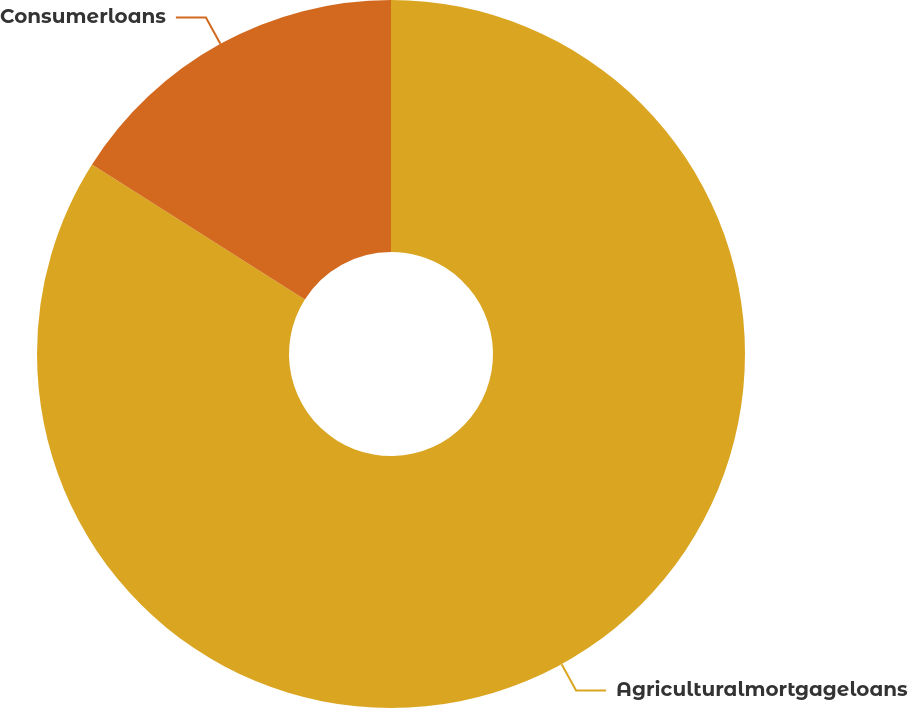Convert chart. <chart><loc_0><loc_0><loc_500><loc_500><pie_chart><fcel>Agriculturalmortgageloans<fcel>Consumerloans<nl><fcel>83.99%<fcel>16.01%<nl></chart> 